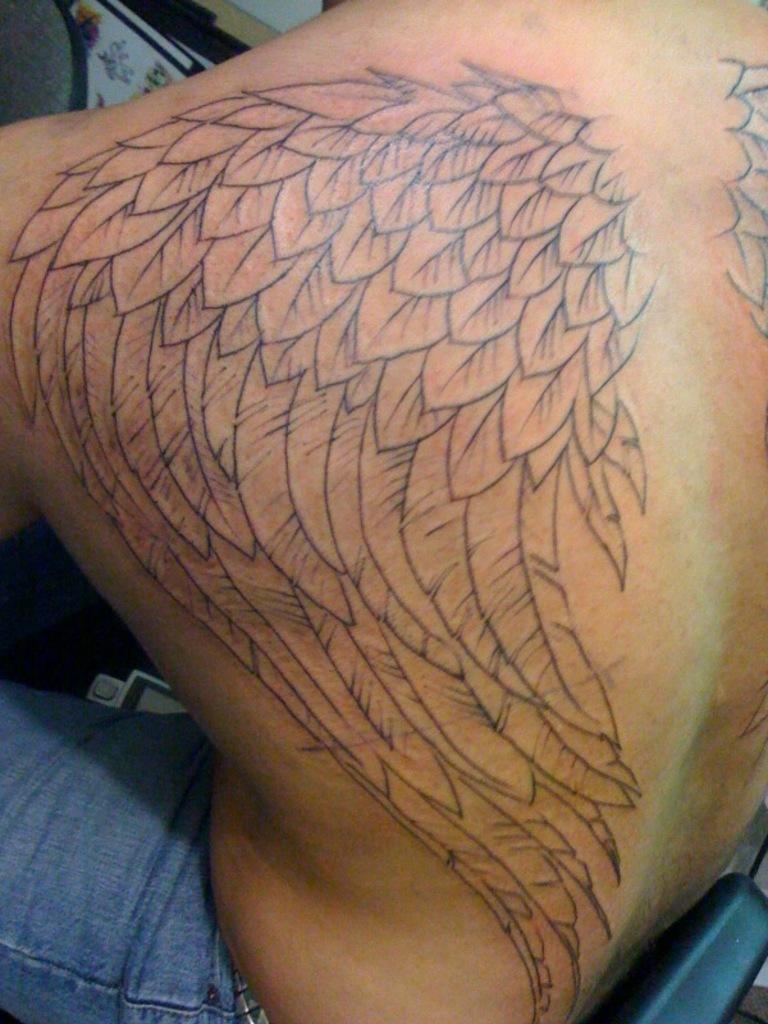Describe this image in one or two sentences. In this image I can see a tattoo on a person's body. 